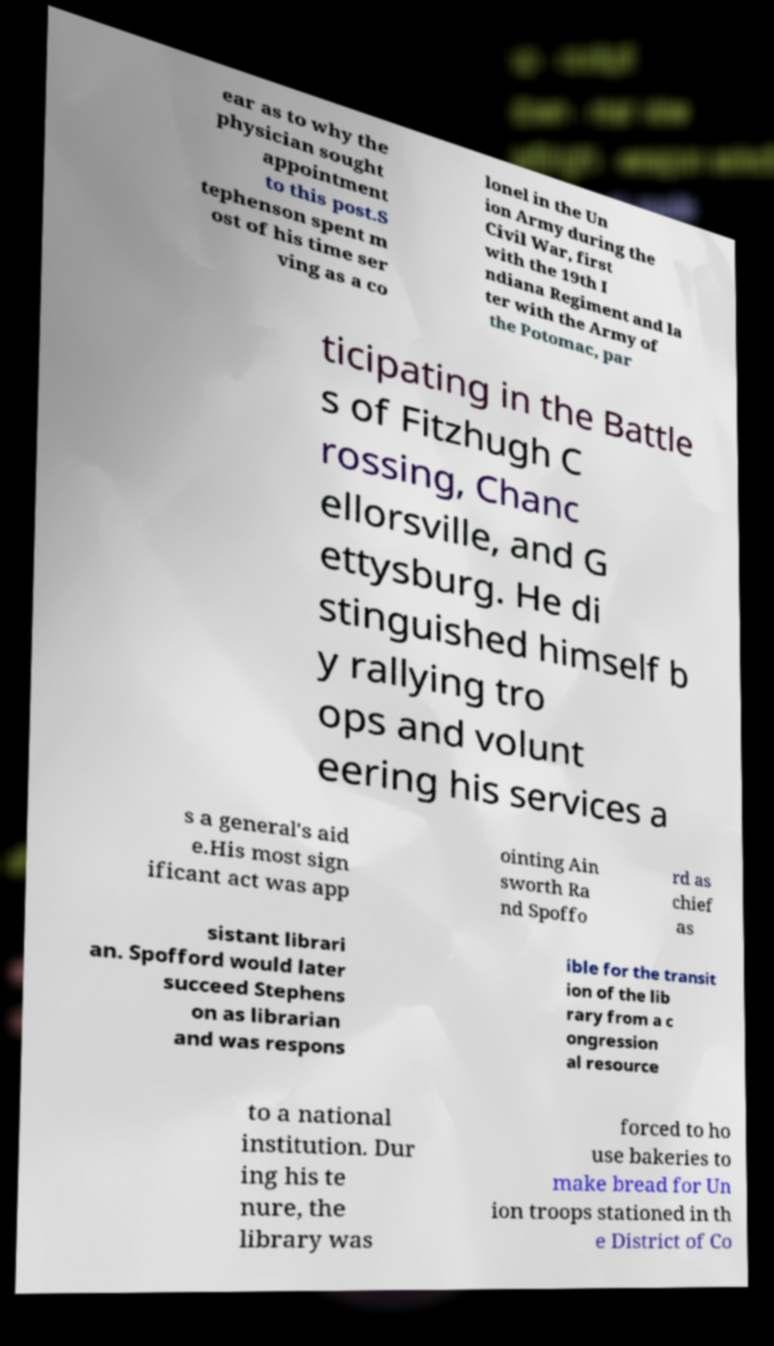There's text embedded in this image that I need extracted. Can you transcribe it verbatim? ear as to why the physician sought appointment to this post.S tephenson spent m ost of his time ser ving as a co lonel in the Un ion Army during the Civil War, first with the 19th I ndiana Regiment and la ter with the Army of the Potomac, par ticipating in the Battle s of Fitzhugh C rossing, Chanc ellorsville, and G ettysburg. He di stinguished himself b y rallying tro ops and volunt eering his services a s a general's aid e.His most sign ificant act was app ointing Ain sworth Ra nd Spoffo rd as chief as sistant librari an. Spofford would later succeed Stephens on as librarian and was respons ible for the transit ion of the lib rary from a c ongression al resource to a national institution. Dur ing his te nure, the library was forced to ho use bakeries to make bread for Un ion troops stationed in th e District of Co 